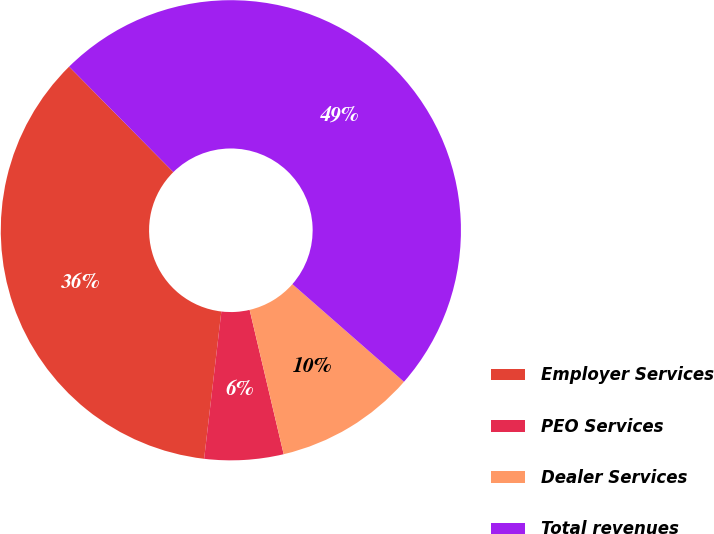Convert chart to OTSL. <chart><loc_0><loc_0><loc_500><loc_500><pie_chart><fcel>Employer Services<fcel>PEO Services<fcel>Dealer Services<fcel>Total revenues<nl><fcel>35.74%<fcel>5.54%<fcel>9.87%<fcel>48.85%<nl></chart> 